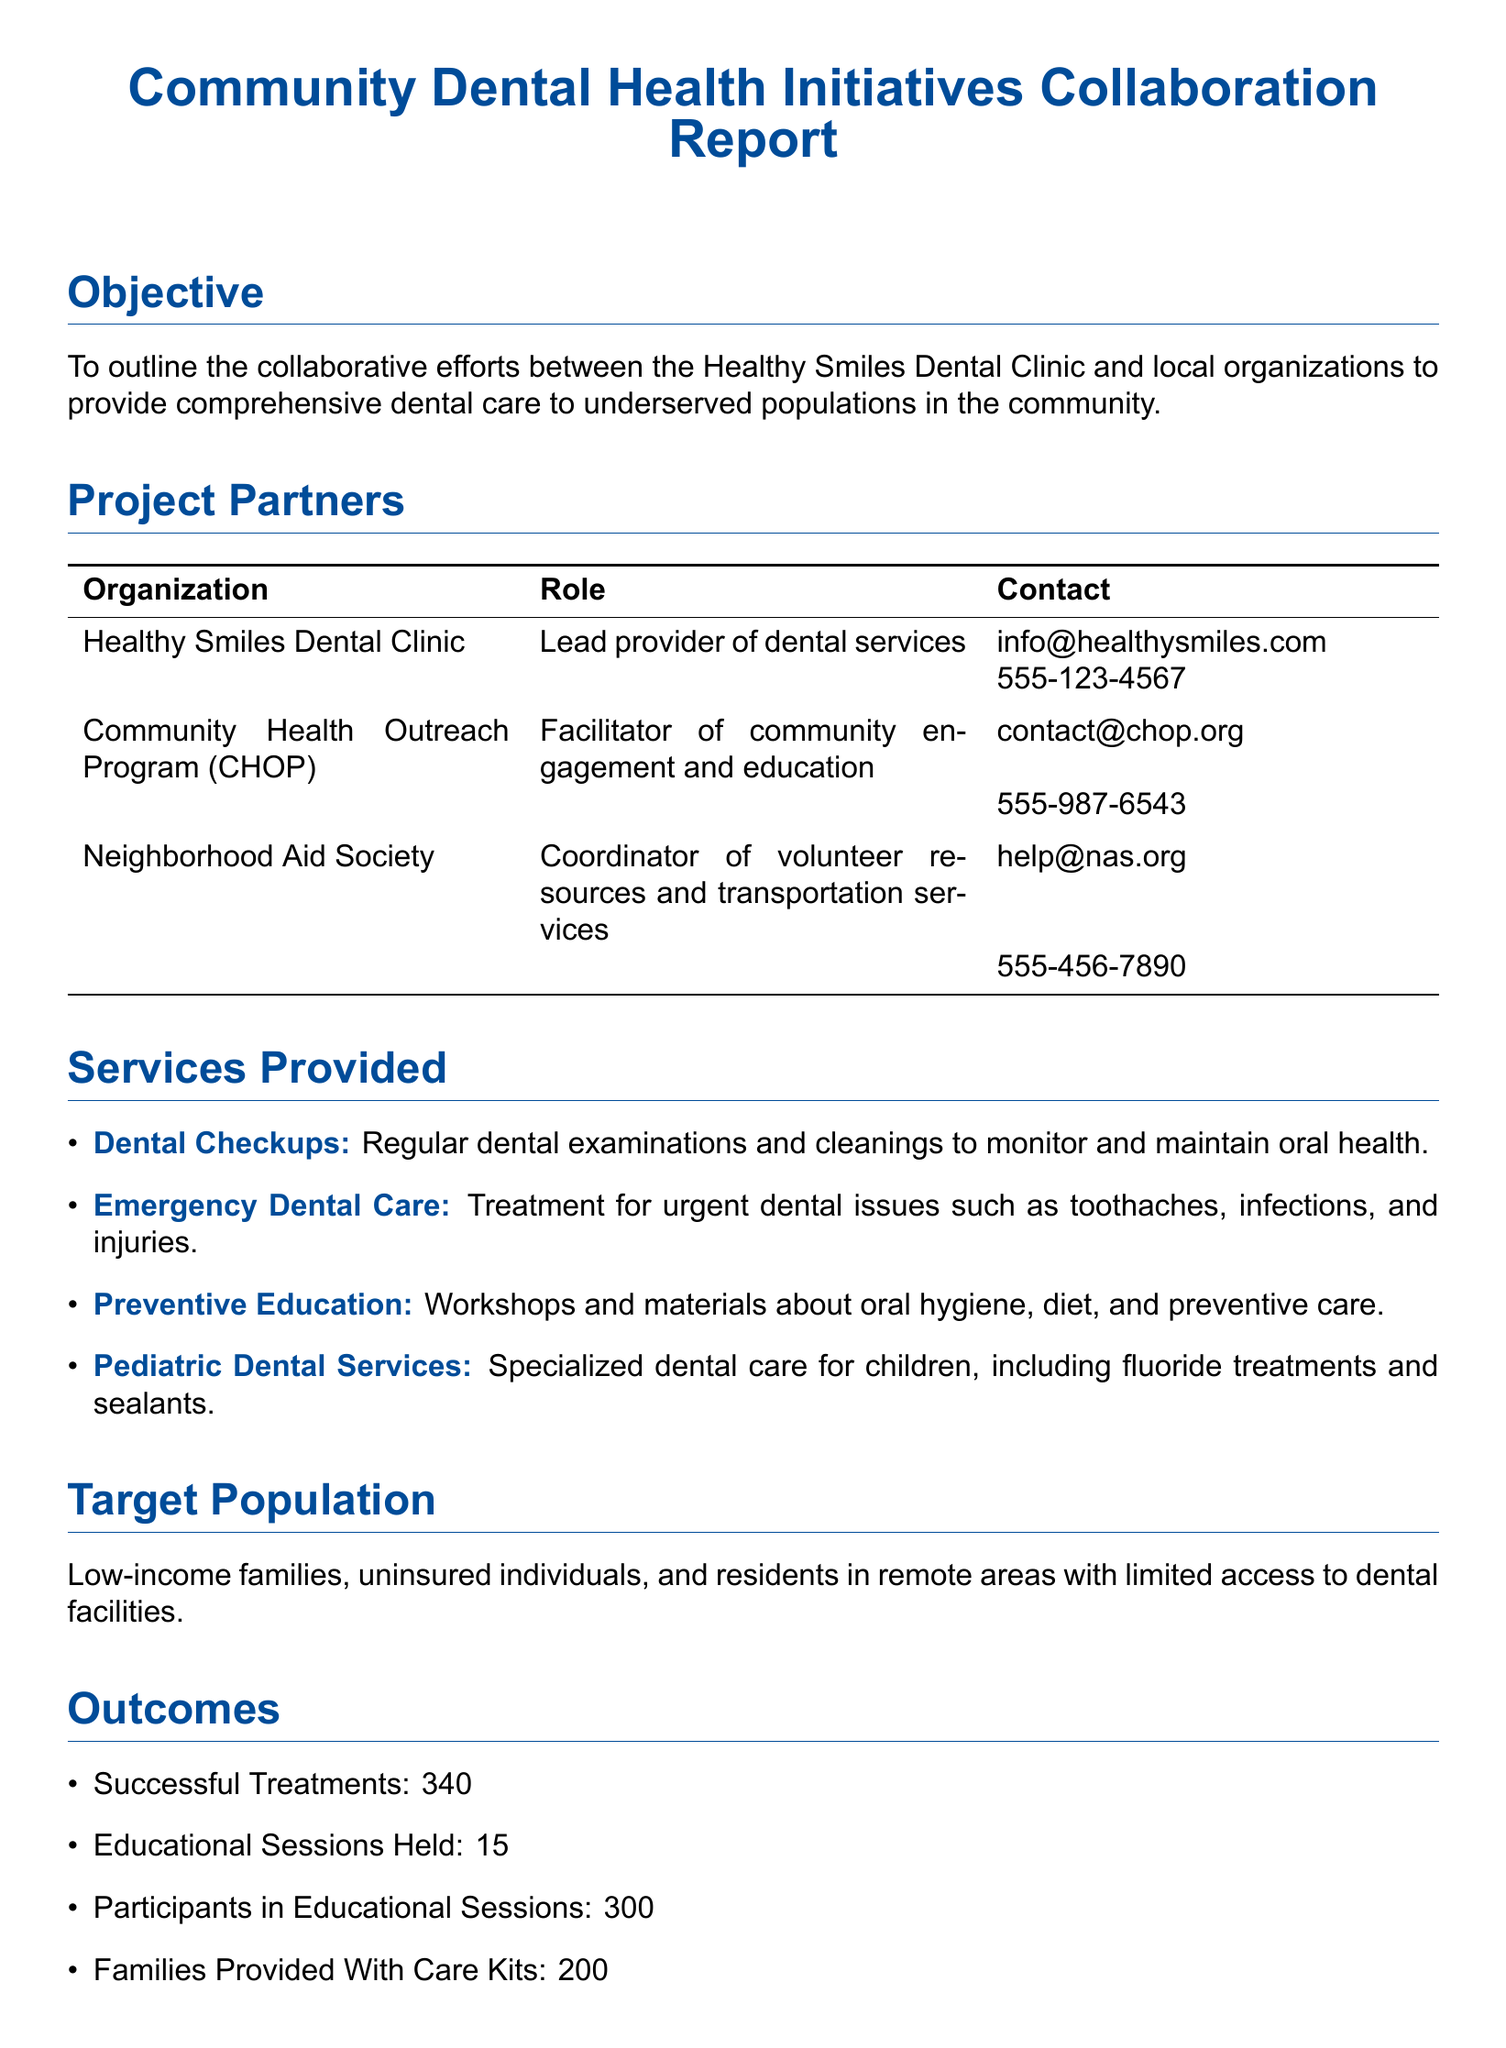What is the main objective of the report? The objective outlines collaborative efforts to provide dental care to underserved populations.
Answer: To outline collaborative efforts Who is the lead provider of dental services? The document specifies Healthy Smiles Dental Clinic as the lead provider.
Answer: Healthy Smiles Dental Clinic How many successful treatments were recorded? The outcome section lists the number of successful treatments conducted.
Answer: 340 What type of care is provided to children? The services section mentions specialized care for children, including fluoride treatments and sealants.
Answer: Pediatric Dental Services What is one of the challenges mentioned in the document? The challenges section describes several issues faced, including limited resources.
Answer: Limited Resources How many educational sessions were held? The number of educational sessions conducted is provided in the outcomes section.
Answer: 15 What future plan involves reaching remote areas? The future plans section includes expanding to mobile units for underserved areas.
Answer: Expand Services Which organization coordinates volunteer resources? The project partners section indicates that the Neighborhood Aid Society coordinates volunteers.
Answer: Neighborhood Aid Society 